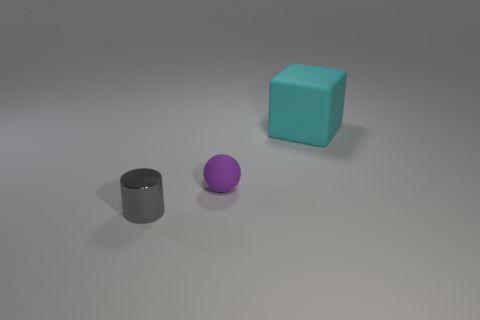Is there any other thing that is the same color as the sphere?
Provide a succinct answer. No. How many objects are big shiny cubes or tiny things to the right of the shiny cylinder?
Ensure brevity in your answer.  1. There is a small thing that is behind the tiny object on the left side of the matte thing that is to the left of the cyan matte object; what is it made of?
Provide a short and direct response. Rubber. What size is the sphere that is made of the same material as the big object?
Ensure brevity in your answer.  Small. What color is the thing on the right side of the matte object that is to the left of the cyan rubber cube?
Give a very brief answer. Cyan. How many small purple spheres have the same material as the cube?
Give a very brief answer. 1. How many metal things are either cylinders or big blue cylinders?
Offer a terse response. 1. There is a ball that is the same size as the gray shiny object; what is it made of?
Your answer should be compact. Rubber. Are there any tiny cubes that have the same material as the purple object?
Your answer should be compact. No. The tiny thing to the right of the thing left of the tiny thing behind the tiny gray shiny thing is what shape?
Your answer should be compact. Sphere. 